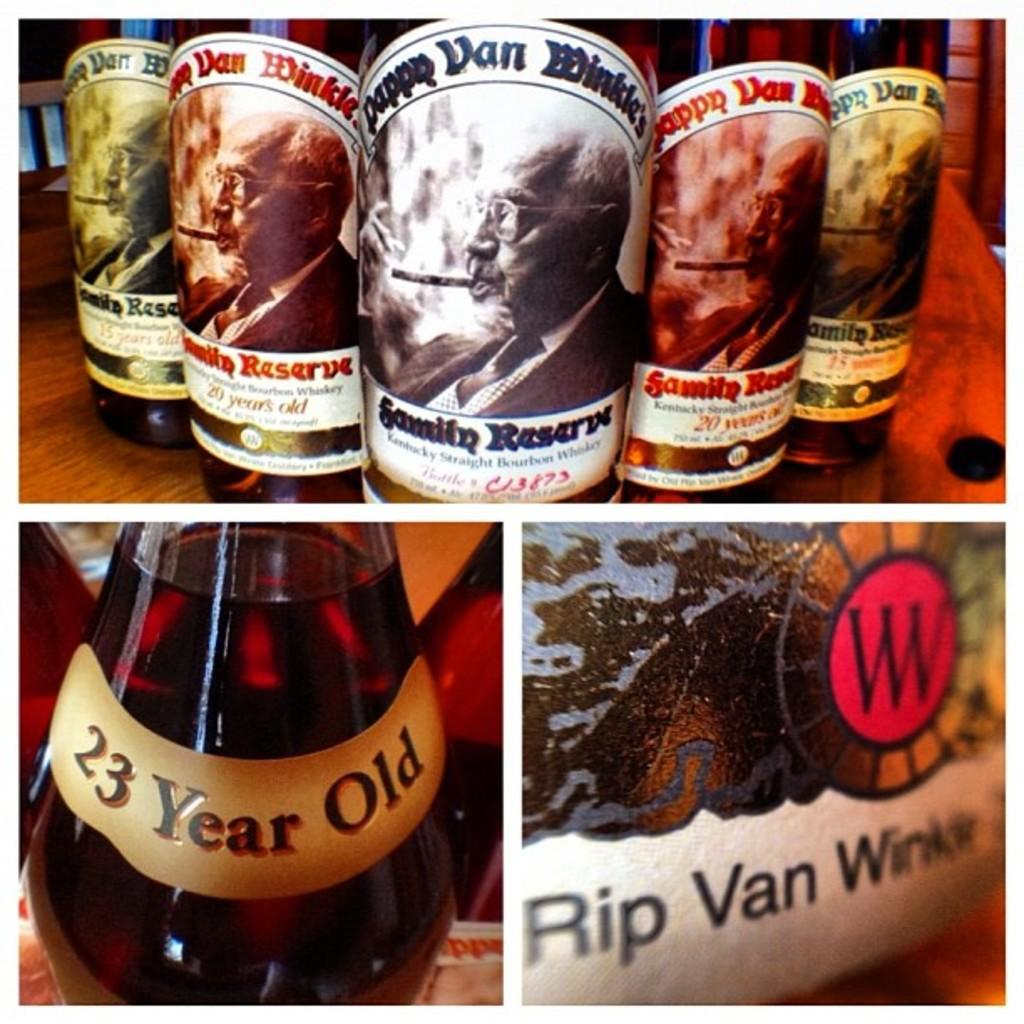<image>
Write a terse but informative summary of the picture. 5 bottles of rip van winkle are sitting together in a table 